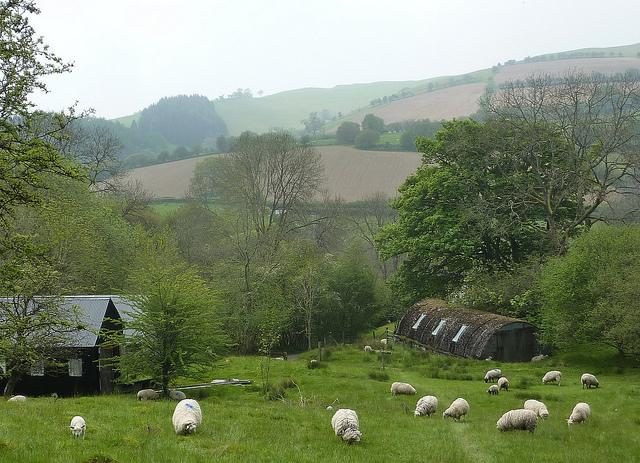Is this a suburb?
Give a very brief answer. No. Does this look like a peaceful place to live?
Be succinct. Yes. Is the building a castle?
Give a very brief answer. No. What is grazing in the field?
Quick response, please. Sheep. 